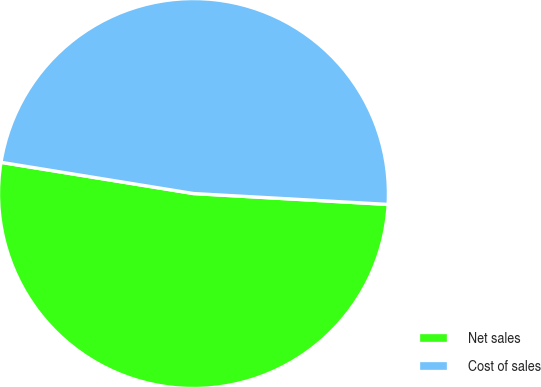Convert chart to OTSL. <chart><loc_0><loc_0><loc_500><loc_500><pie_chart><fcel>Net sales<fcel>Cost of sales<nl><fcel>51.67%<fcel>48.33%<nl></chart> 